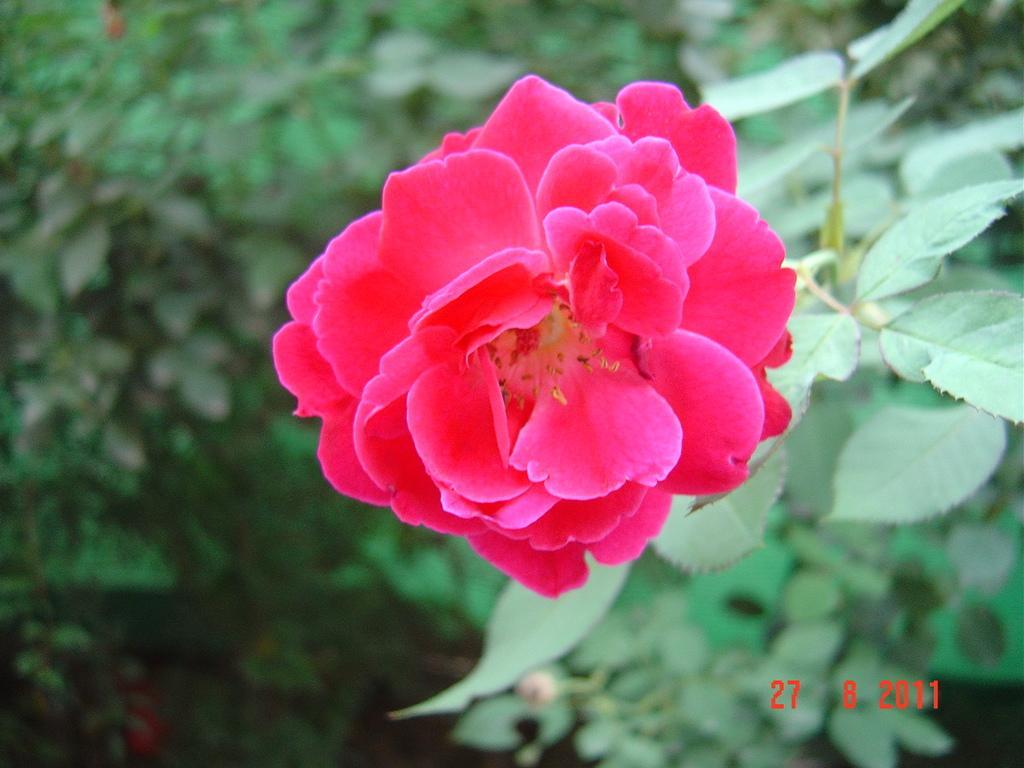Could you give a brief overview of what you see in this image? In this image there are plants and we can see a flower which is in pink color. 